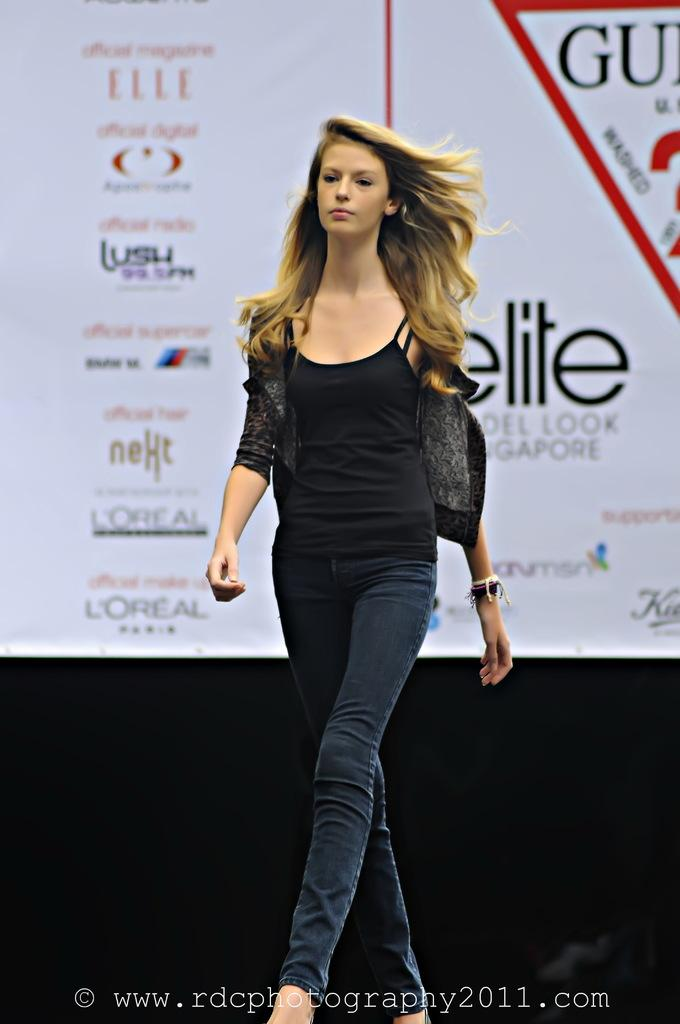What is the main subject of the image? There is a woman in the image. What is the woman doing in the image? The woman is walking. What is the woman wearing in the image? The woman is wearing a black top. What can be seen in the background of the image? There is a banner in the background of the image. What is written on the banner? The banner has text on it. What type of brake can be seen on the road in the image? There is no road or brake present in the image; it features a woman walking with a banner in the background. 